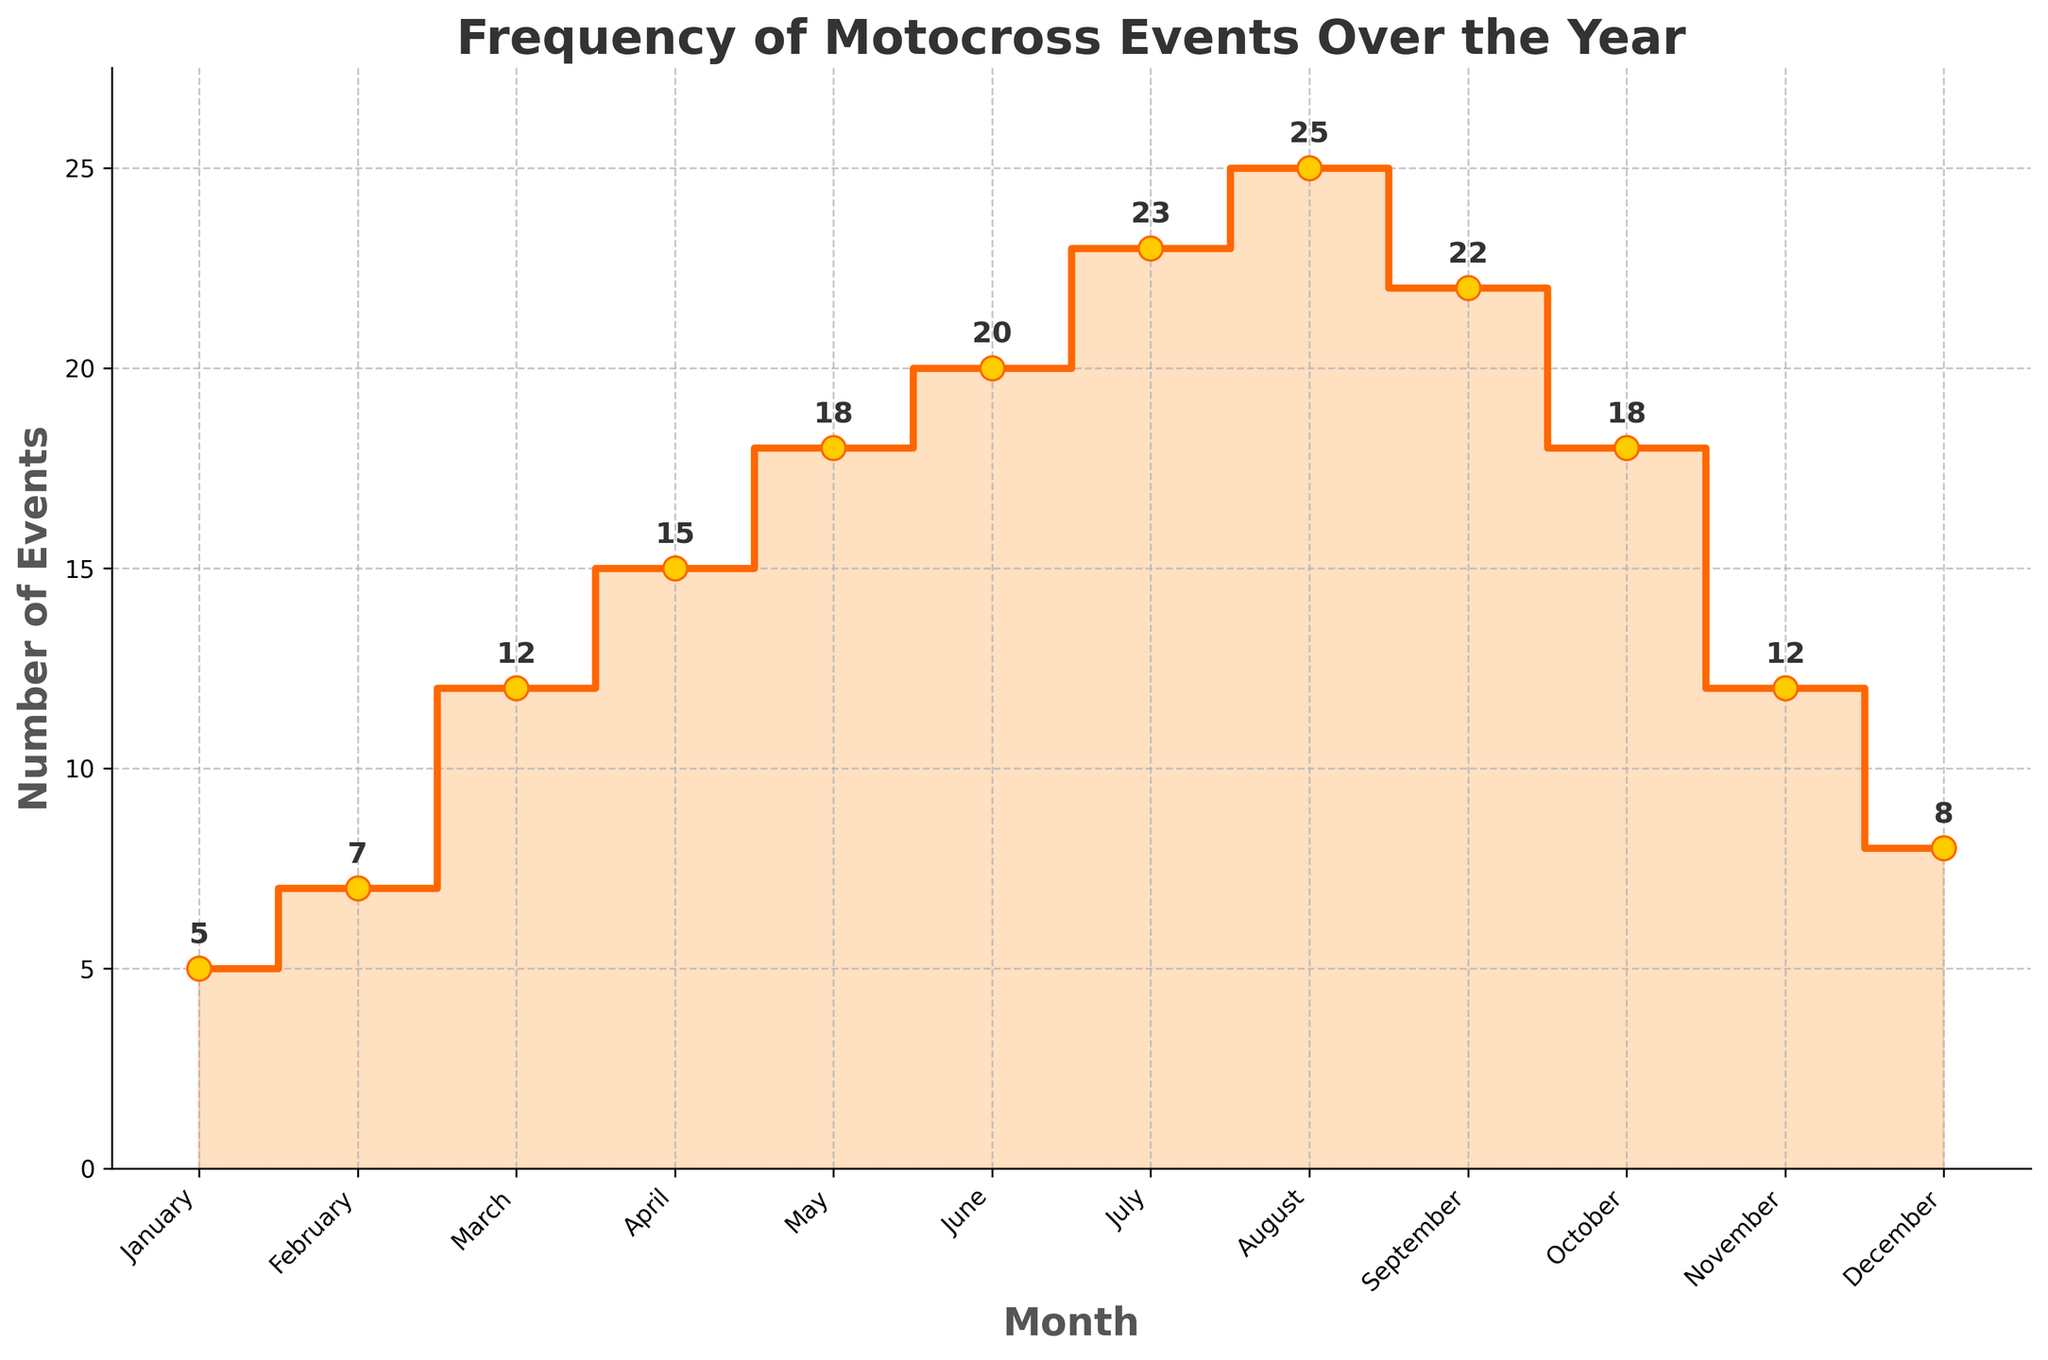What's the title of the figure? The title is displayed at the top center of the figure in large, bold font. It reads "Frequency of Motocross Events Over the Year."
Answer: Frequency of Motocross Events Over the Year What is the number of Motocross events in July? Look for the data point labeled "July" on the x-axis and find the corresponding value on the y-axis. The chart shows a point at around 23 events for July.
Answer: 23 How many more events are there in March compared to January? Locate the number of events for both March and January on the y-axis. March has 12 events and January has 5. Subtract the January value from the March value: 12 - 5 = 7.
Answer: 7 What is the overall trend of Motocross events over the year? Follow the step plot from January to December. The number of events generally increases from January to August, then decreases from September to December.
Answer: Increases till August, then decreases Which month has the highest number of Motocross events, and what is that number? Find the highest point on the step plot. The highest point is in August with 25 events.
Answer: August, 25 Compare the number of events in May and October. Which month had more events and by how many? Locate the data points for May and October. May has 18 events and October has 18 events. Subtract the lower value from the higher one to find the difference: 18 - 18 = 0.
Answer: May and October, 0 What is the difference between the number of events in April and November? Locate the number of events for both April and November. April has 15 events and November has 12. Subtract November’s value from April’s value: 15 - 12 = 3.
Answer: 3 What is the average number of events from June to August? The number of events for June, July, and August are 20, 23, and 25, respectively. Add these numbers and divide by 3 to get the average: (20 + 23 + 25) / 3 = 68 / 3 ≈ 22.67.
Answer: 22.67 How does the number of events in February compare to September? Locate the data points for February and September. February shows 7 events and September has 22. Compare these values directly.
Answer: September has more events than February 